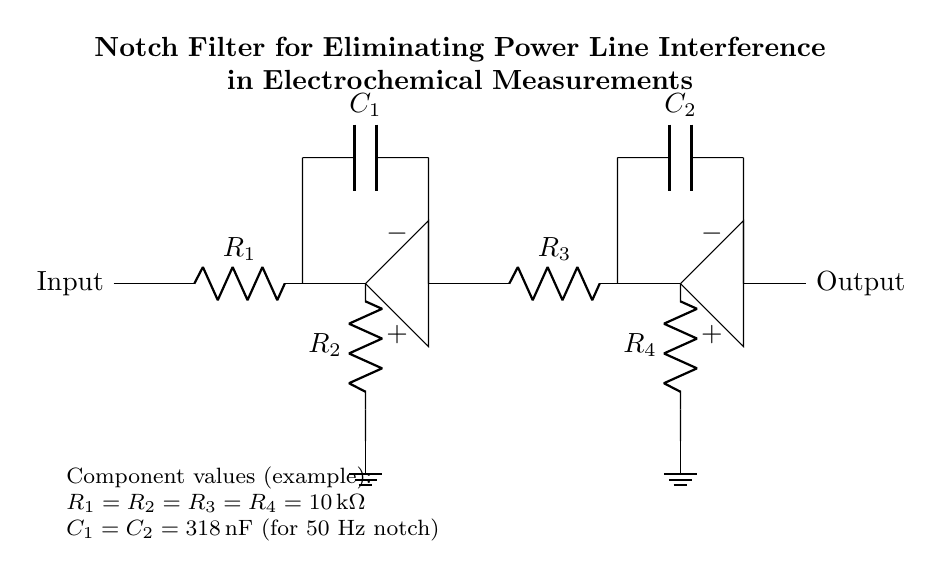What is the type of filter in this circuit? The circuit diagram shows a notch filter designed to eliminate specific frequency interference. Notch filters are characterized by their ability to attenuate a narrow band of frequencies while allowing others to pass through.
Answer: Notch filter What is the frequency that this filter is designed to eliminate? The component values provided indicate that this notch filter is designed for a frequency of 50 Hz, which is the typical frequency of power line interference in many regions.
Answer: 50 Hz How many operational amplifiers are used in this circuit? The diagram clearly depicts two operational amplifier stages, which are essential in the design of the notch filter to achieve the desired amplification and filtering characteristics.
Answer: Two What are the resistor values in this circuit? The circuit specifies that all the resistor values (R1, R2, R3, R4) are equal to 10 kilo-ohms, indicating a uniform design which can simplify analysis and tuning of the filter's response.
Answer: 10 kilo-ohms What is the purpose of the capacitors in this notch filter? The capacitors (C1 and C2) in the circuit work in conjunction with the resistors to define the cutoff frequency of the notch filter. They store and release energy, affecting the filter's frequency response, especially at the notched frequency.
Answer: Energy storage and frequency response What would happen if R1 was replaced with a higher value? If R1 is replaced with a higher value, it would change the impedance of the circuit, potentially shifting the notch frequency and altering the filter's behavior, which could reduce its effectiveness at eliminating the intended frequency.
Answer: Shift in notch frequency What is the main advantage of using a notch filter in electrochemical measurements? A notch filter helps reduce unwanted noise from power line interference, improving the signal-to-noise ratio in electrochemical measurements, thereby allowing for more accurate and reliable results.
Answer: Improved signal-to-noise ratio 